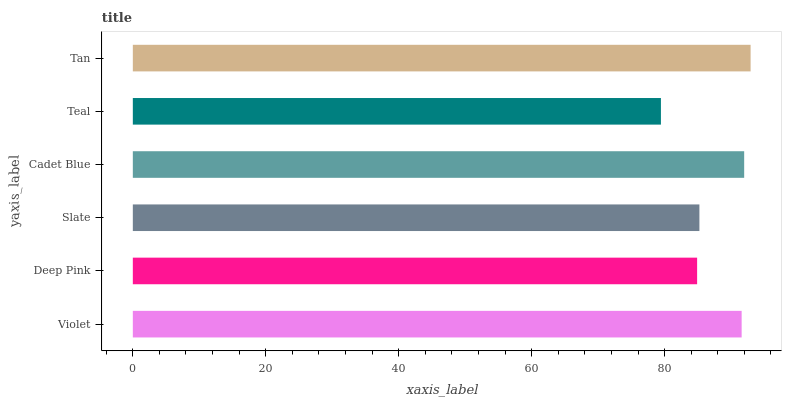Is Teal the minimum?
Answer yes or no. Yes. Is Tan the maximum?
Answer yes or no. Yes. Is Deep Pink the minimum?
Answer yes or no. No. Is Deep Pink the maximum?
Answer yes or no. No. Is Violet greater than Deep Pink?
Answer yes or no. Yes. Is Deep Pink less than Violet?
Answer yes or no. Yes. Is Deep Pink greater than Violet?
Answer yes or no. No. Is Violet less than Deep Pink?
Answer yes or no. No. Is Violet the high median?
Answer yes or no. Yes. Is Slate the low median?
Answer yes or no. Yes. Is Deep Pink the high median?
Answer yes or no. No. Is Tan the low median?
Answer yes or no. No. 